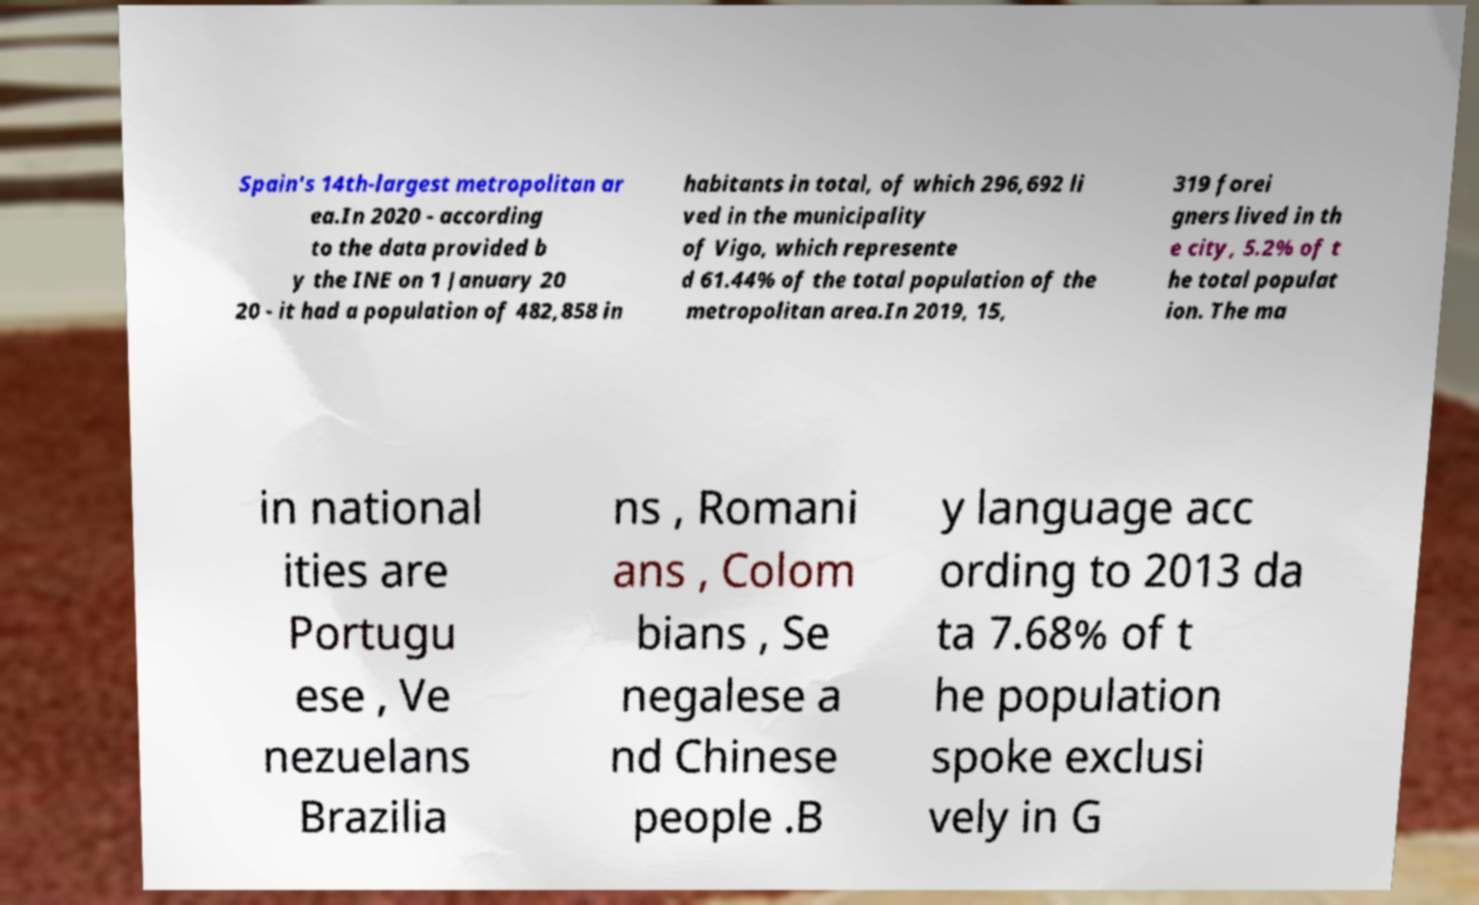Could you assist in decoding the text presented in this image and type it out clearly? Spain's 14th-largest metropolitan ar ea.In 2020 - according to the data provided b y the INE on 1 January 20 20 - it had a population of 482,858 in habitants in total, of which 296,692 li ved in the municipality of Vigo, which represente d 61.44% of the total population of the metropolitan area.In 2019, 15, 319 forei gners lived in th e city, 5.2% of t he total populat ion. The ma in national ities are Portugu ese , Ve nezuelans Brazilia ns , Romani ans , Colom bians , Se negalese a nd Chinese people .B y language acc ording to 2013 da ta 7.68% of t he population spoke exclusi vely in G 